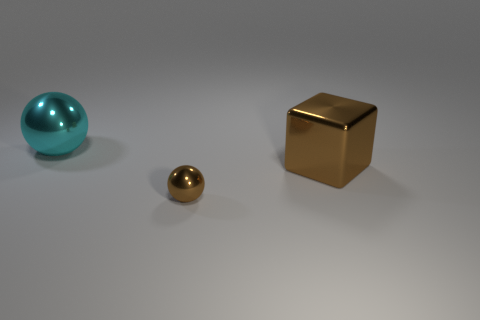Add 3 big cyan spheres. How many objects exist? 6 Subtract all balls. How many objects are left? 1 Add 2 large shiny things. How many large shiny things exist? 4 Subtract 0 yellow spheres. How many objects are left? 3 Subtract all tiny balls. Subtract all cyan metallic objects. How many objects are left? 1 Add 2 small metallic spheres. How many small metallic spheres are left? 3 